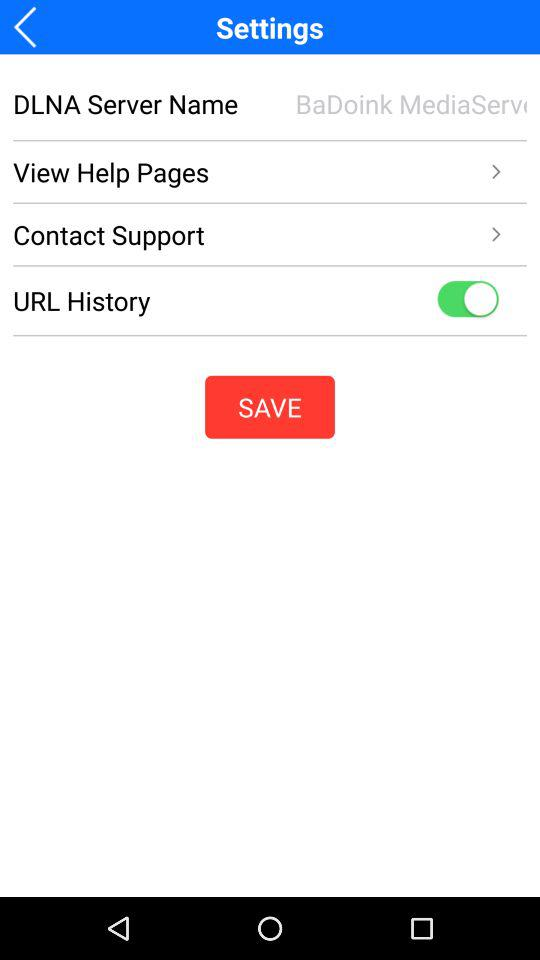What is the "DLNA Server Name"? The server name is "BaDoink MediaServ". 